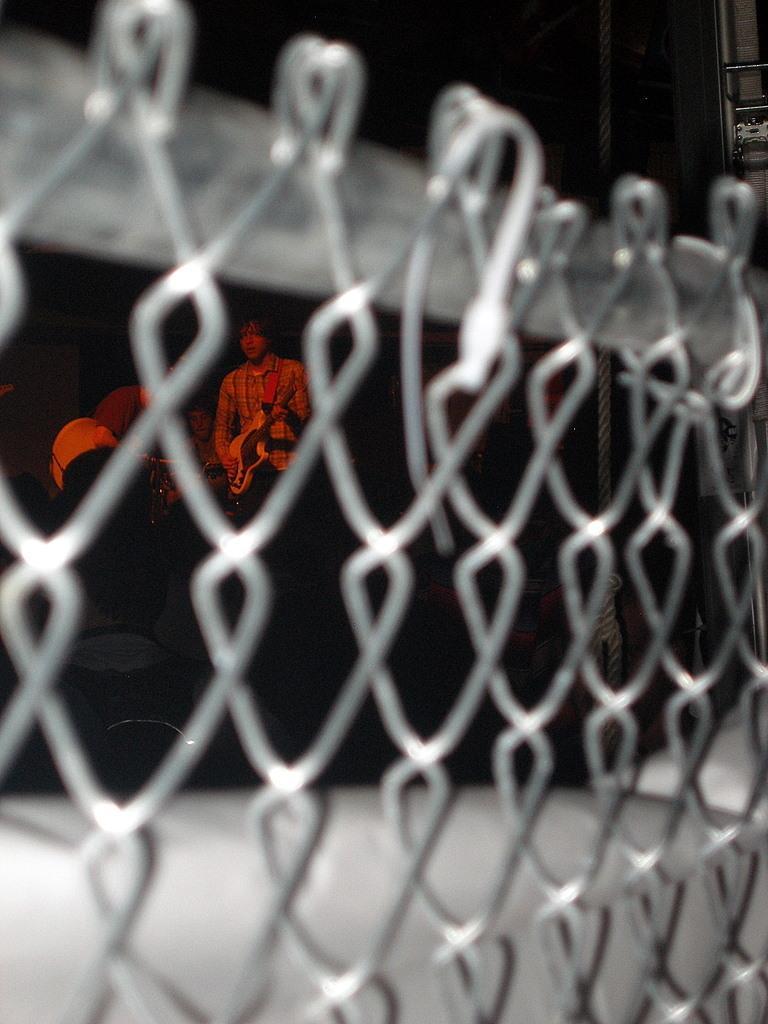In one or two sentences, can you explain what this image depicts? In this image we can see the fence. Through the fence we can see some people. The background of the image is blur. 